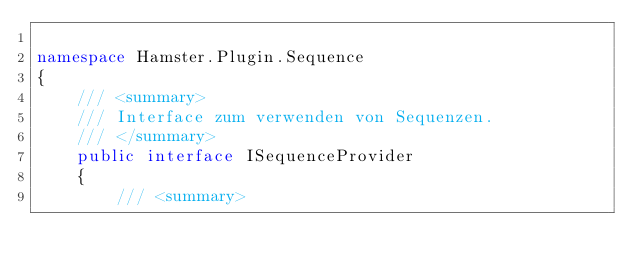Convert code to text. <code><loc_0><loc_0><loc_500><loc_500><_C#_>
namespace Hamster.Plugin.Sequence
{
    /// <summary>
    /// Interface zum verwenden von Sequenzen.
    /// </summary>
    public interface ISequenceProvider
    {
        /// <summary></code> 